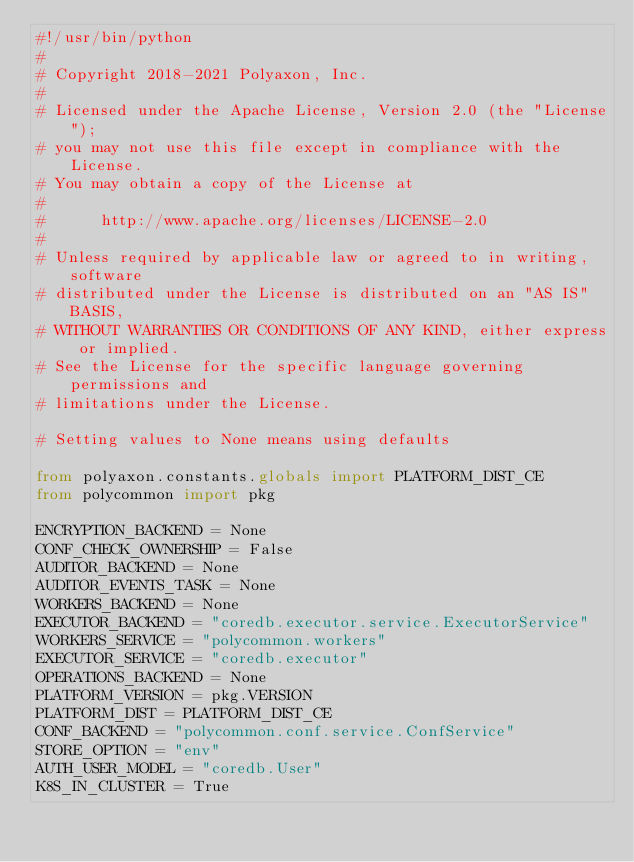<code> <loc_0><loc_0><loc_500><loc_500><_Python_>#!/usr/bin/python
#
# Copyright 2018-2021 Polyaxon, Inc.
#
# Licensed under the Apache License, Version 2.0 (the "License");
# you may not use this file except in compliance with the License.
# You may obtain a copy of the License at
#
#      http://www.apache.org/licenses/LICENSE-2.0
#
# Unless required by applicable law or agreed to in writing, software
# distributed under the License is distributed on an "AS IS" BASIS,
# WITHOUT WARRANTIES OR CONDITIONS OF ANY KIND, either express or implied.
# See the License for the specific language governing permissions and
# limitations under the License.

# Setting values to None means using defaults

from polyaxon.constants.globals import PLATFORM_DIST_CE
from polycommon import pkg

ENCRYPTION_BACKEND = None
CONF_CHECK_OWNERSHIP = False
AUDITOR_BACKEND = None
AUDITOR_EVENTS_TASK = None
WORKERS_BACKEND = None
EXECUTOR_BACKEND = "coredb.executor.service.ExecutorService"
WORKERS_SERVICE = "polycommon.workers"
EXECUTOR_SERVICE = "coredb.executor"
OPERATIONS_BACKEND = None
PLATFORM_VERSION = pkg.VERSION
PLATFORM_DIST = PLATFORM_DIST_CE
CONF_BACKEND = "polycommon.conf.service.ConfService"
STORE_OPTION = "env"
AUTH_USER_MODEL = "coredb.User"
K8S_IN_CLUSTER = True
</code> 